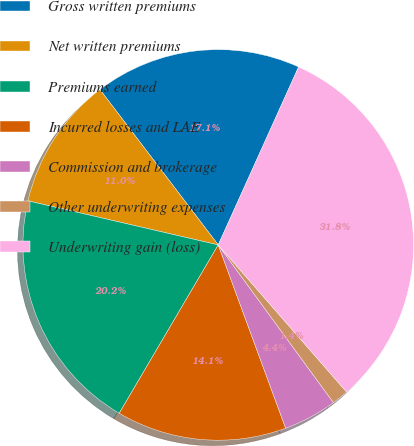Convert chart to OTSL. <chart><loc_0><loc_0><loc_500><loc_500><pie_chart><fcel>Gross written premiums<fcel>Net written premiums<fcel>Premiums earned<fcel>Incurred losses and LAE<fcel>Commission and brokerage<fcel>Other underwriting expenses<fcel>Underwriting gain (loss)<nl><fcel>17.11%<fcel>11.02%<fcel>20.16%<fcel>14.07%<fcel>4.43%<fcel>1.38%<fcel>31.83%<nl></chart> 